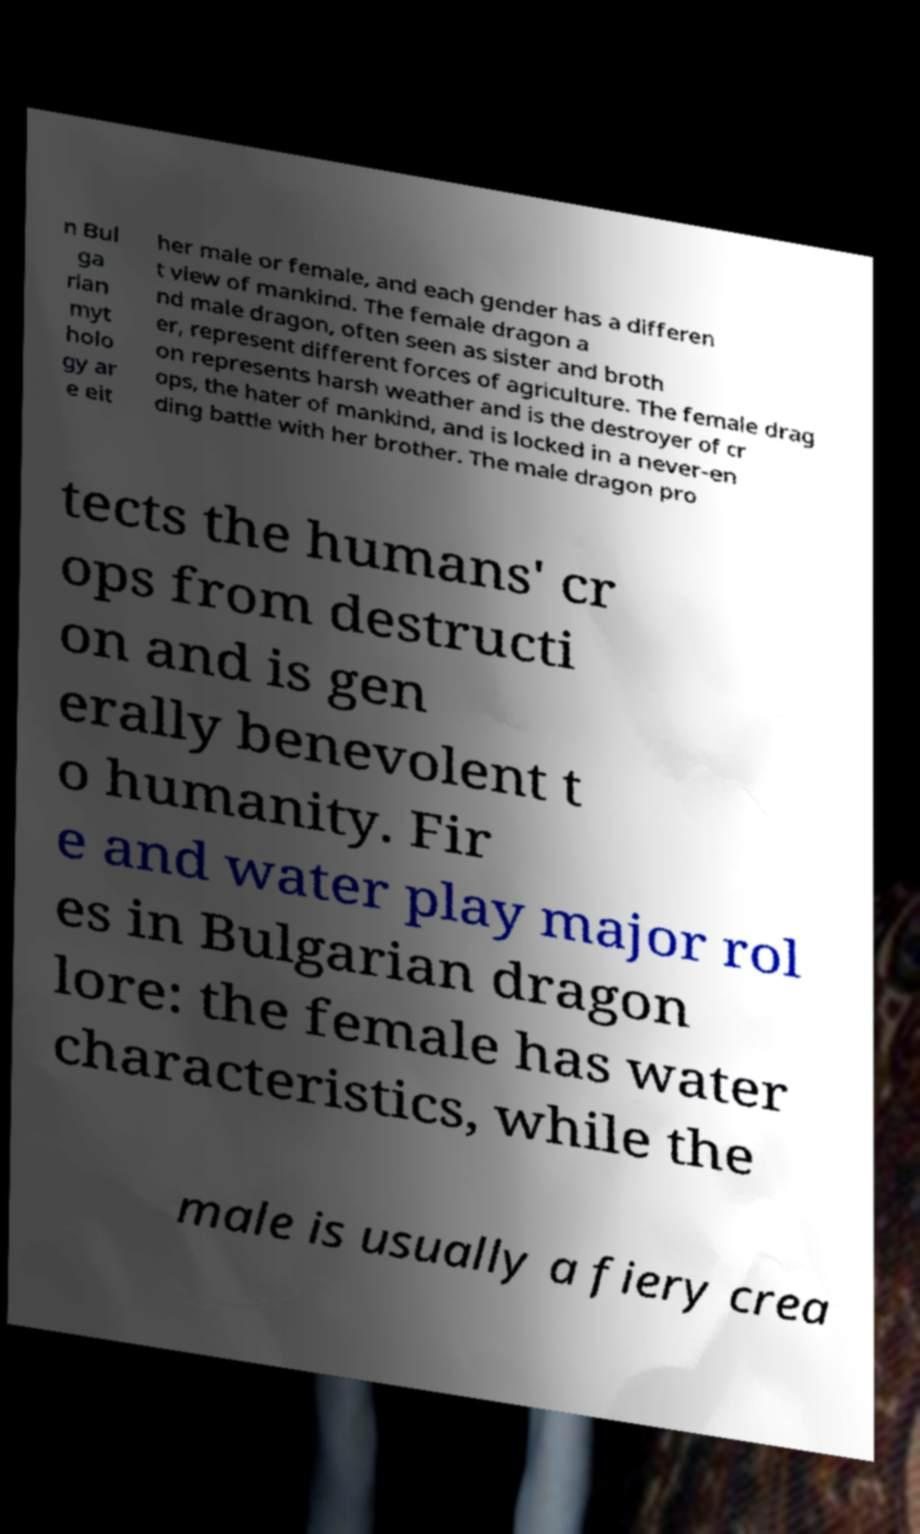I need the written content from this picture converted into text. Can you do that? n Bul ga rian myt holo gy ar e eit her male or female, and each gender has a differen t view of mankind. The female dragon a nd male dragon, often seen as sister and broth er, represent different forces of agriculture. The female drag on represents harsh weather and is the destroyer of cr ops, the hater of mankind, and is locked in a never-en ding battle with her brother. The male dragon pro tects the humans' cr ops from destructi on and is gen erally benevolent t o humanity. Fir e and water play major rol es in Bulgarian dragon lore: the female has water characteristics, while the male is usually a fiery crea 